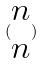Convert formula to latex. <formula><loc_0><loc_0><loc_500><loc_500>( \begin{matrix} n \\ n \end{matrix} )</formula> 